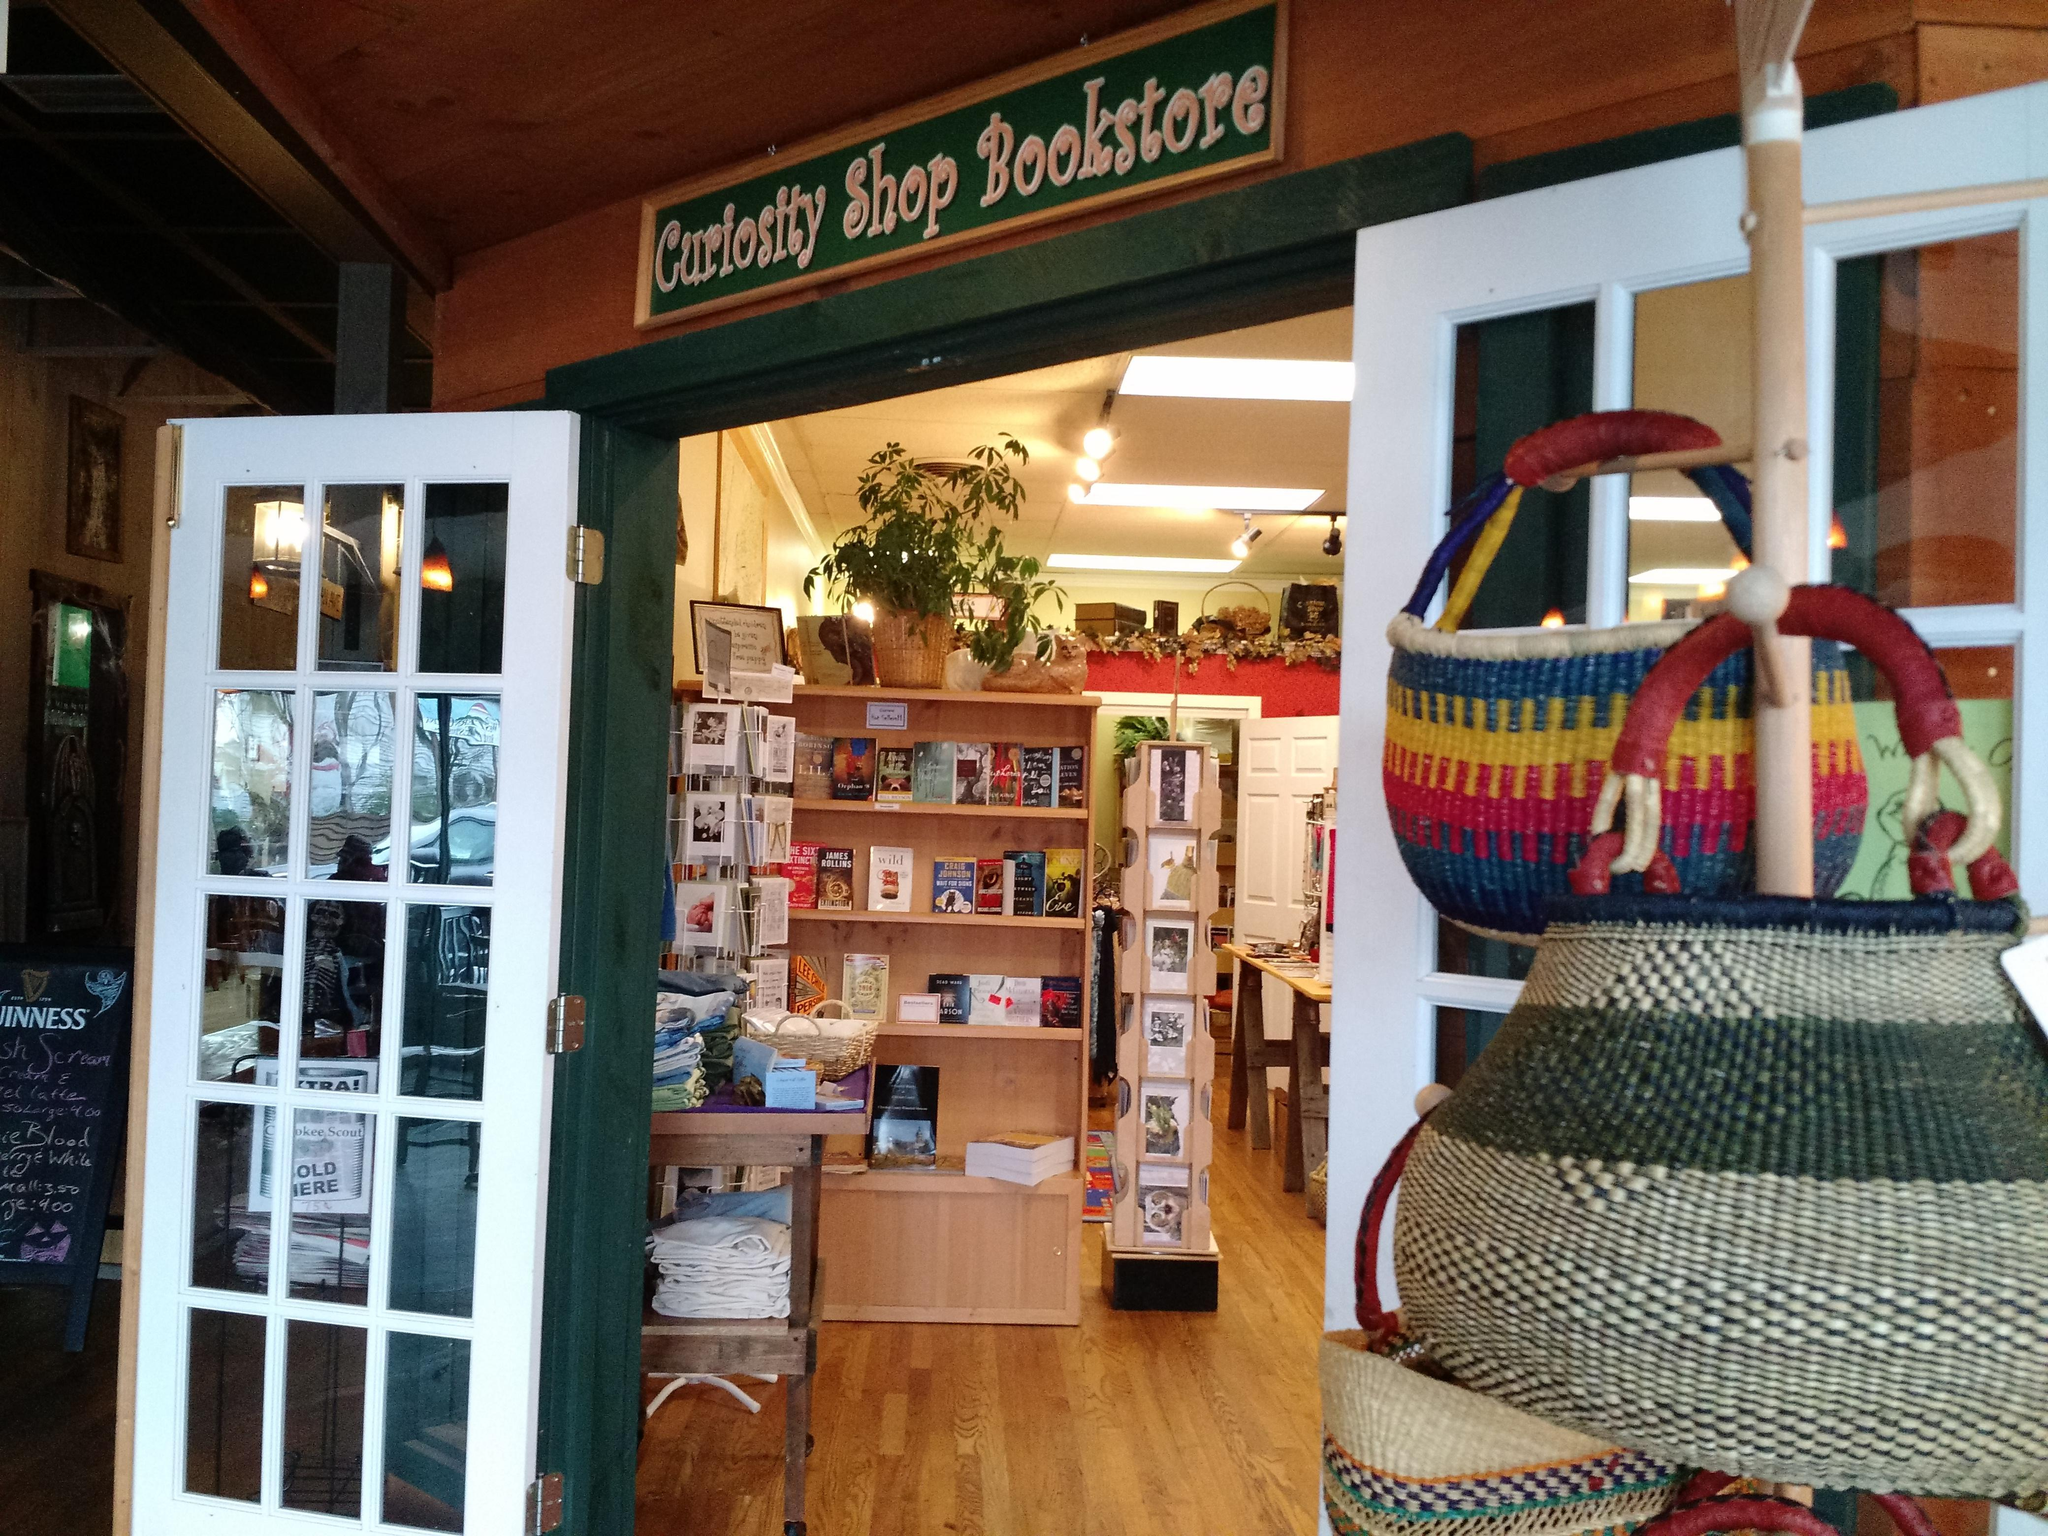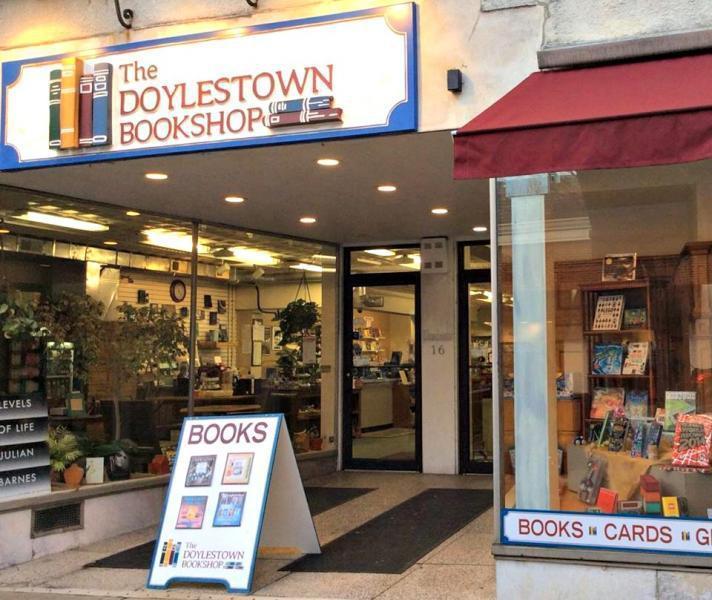The first image is the image on the left, the second image is the image on the right. Considering the images on both sides, is "Outside storefront views of local bookstores." valid? Answer yes or no. Yes. The first image is the image on the left, the second image is the image on the right. Assess this claim about the two images: "Both images show merchandise displayed inside an exterior window.". Correct or not? Answer yes or no. No. 